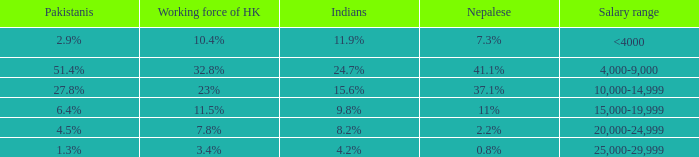If the nepalese is 37.1%, what is the working force of HK? 23%. 